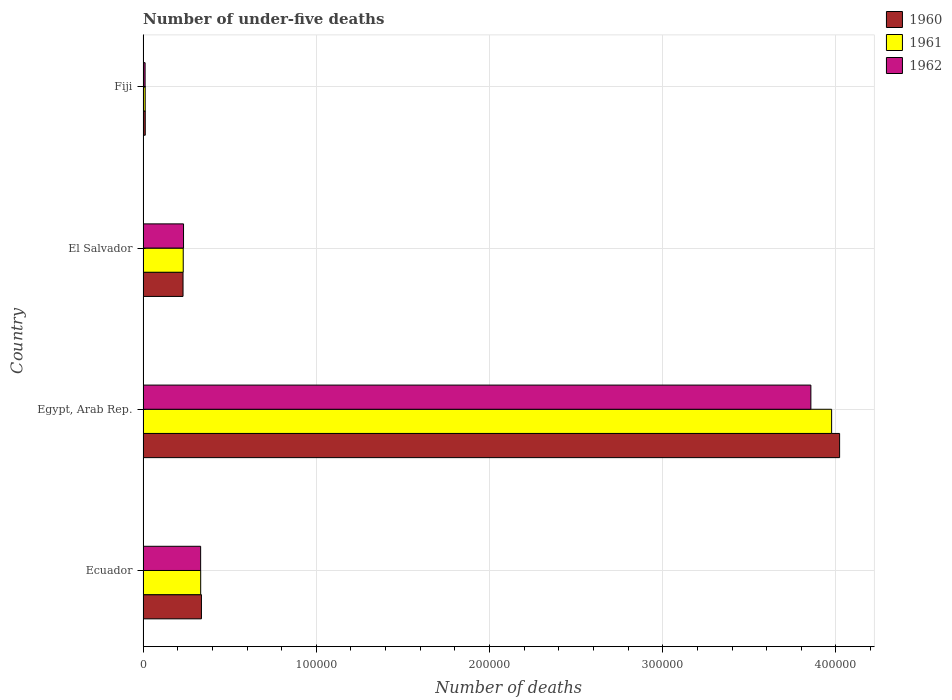Are the number of bars per tick equal to the number of legend labels?
Your response must be concise. Yes. Are the number of bars on each tick of the Y-axis equal?
Offer a very short reply. Yes. How many bars are there on the 4th tick from the top?
Offer a terse response. 3. What is the label of the 1st group of bars from the top?
Your answer should be very brief. Fiji. What is the number of under-five deaths in 1960 in Egypt, Arab Rep.?
Your response must be concise. 4.02e+05. Across all countries, what is the maximum number of under-five deaths in 1961?
Your response must be concise. 3.98e+05. Across all countries, what is the minimum number of under-five deaths in 1961?
Keep it short and to the point. 1222. In which country was the number of under-five deaths in 1962 maximum?
Offer a terse response. Egypt, Arab Rep. In which country was the number of under-five deaths in 1962 minimum?
Provide a short and direct response. Fiji. What is the total number of under-five deaths in 1961 in the graph?
Your answer should be very brief. 4.55e+05. What is the difference between the number of under-five deaths in 1960 in Egypt, Arab Rep. and that in El Salvador?
Give a very brief answer. 3.79e+05. What is the difference between the number of under-five deaths in 1962 in El Salvador and the number of under-five deaths in 1960 in Fiji?
Give a very brief answer. 2.21e+04. What is the average number of under-five deaths in 1961 per country?
Your response must be concise. 1.14e+05. In how many countries, is the number of under-five deaths in 1960 greater than 180000 ?
Ensure brevity in your answer.  1. What is the ratio of the number of under-five deaths in 1962 in El Salvador to that in Fiji?
Your answer should be compact. 19.87. Is the number of under-five deaths in 1960 in Egypt, Arab Rep. less than that in Fiji?
Give a very brief answer. No. What is the difference between the highest and the second highest number of under-five deaths in 1960?
Your response must be concise. 3.68e+05. What is the difference between the highest and the lowest number of under-five deaths in 1960?
Your response must be concise. 4.01e+05. Is the sum of the number of under-five deaths in 1961 in Egypt, Arab Rep. and Fiji greater than the maximum number of under-five deaths in 1960 across all countries?
Offer a very short reply. No. What does the 1st bar from the bottom in Egypt, Arab Rep. represents?
Your answer should be compact. 1960. Is it the case that in every country, the sum of the number of under-five deaths in 1962 and number of under-five deaths in 1961 is greater than the number of under-five deaths in 1960?
Your answer should be very brief. Yes. Does the graph contain any zero values?
Keep it short and to the point. No. Does the graph contain grids?
Your answer should be compact. Yes. How many legend labels are there?
Your answer should be compact. 3. What is the title of the graph?
Provide a succinct answer. Number of under-five deaths. Does "1964" appear as one of the legend labels in the graph?
Your answer should be very brief. No. What is the label or title of the X-axis?
Your answer should be compact. Number of deaths. What is the label or title of the Y-axis?
Ensure brevity in your answer.  Country. What is the Number of deaths of 1960 in Ecuador?
Make the answer very short. 3.37e+04. What is the Number of deaths of 1961 in Ecuador?
Ensure brevity in your answer.  3.33e+04. What is the Number of deaths of 1962 in Ecuador?
Your answer should be very brief. 3.32e+04. What is the Number of deaths in 1960 in Egypt, Arab Rep.?
Offer a very short reply. 4.02e+05. What is the Number of deaths of 1961 in Egypt, Arab Rep.?
Provide a succinct answer. 3.98e+05. What is the Number of deaths in 1962 in Egypt, Arab Rep.?
Offer a very short reply. 3.86e+05. What is the Number of deaths of 1960 in El Salvador?
Keep it short and to the point. 2.31e+04. What is the Number of deaths in 1961 in El Salvador?
Your answer should be compact. 2.32e+04. What is the Number of deaths in 1962 in El Salvador?
Your answer should be compact. 2.34e+04. What is the Number of deaths of 1960 in Fiji?
Offer a very short reply. 1263. What is the Number of deaths of 1961 in Fiji?
Your response must be concise. 1222. What is the Number of deaths in 1962 in Fiji?
Make the answer very short. 1176. Across all countries, what is the maximum Number of deaths of 1960?
Give a very brief answer. 4.02e+05. Across all countries, what is the maximum Number of deaths in 1961?
Offer a very short reply. 3.98e+05. Across all countries, what is the maximum Number of deaths of 1962?
Keep it short and to the point. 3.86e+05. Across all countries, what is the minimum Number of deaths of 1960?
Your answer should be compact. 1263. Across all countries, what is the minimum Number of deaths of 1961?
Give a very brief answer. 1222. Across all countries, what is the minimum Number of deaths in 1962?
Offer a terse response. 1176. What is the total Number of deaths in 1960 in the graph?
Keep it short and to the point. 4.60e+05. What is the total Number of deaths in 1961 in the graph?
Offer a very short reply. 4.55e+05. What is the total Number of deaths of 1962 in the graph?
Your answer should be very brief. 4.43e+05. What is the difference between the Number of deaths in 1960 in Ecuador and that in Egypt, Arab Rep.?
Your answer should be compact. -3.68e+05. What is the difference between the Number of deaths of 1961 in Ecuador and that in Egypt, Arab Rep.?
Provide a short and direct response. -3.64e+05. What is the difference between the Number of deaths in 1962 in Ecuador and that in Egypt, Arab Rep.?
Keep it short and to the point. -3.52e+05. What is the difference between the Number of deaths of 1960 in Ecuador and that in El Salvador?
Ensure brevity in your answer.  1.06e+04. What is the difference between the Number of deaths in 1961 in Ecuador and that in El Salvador?
Keep it short and to the point. 1.01e+04. What is the difference between the Number of deaths of 1962 in Ecuador and that in El Salvador?
Offer a terse response. 9875. What is the difference between the Number of deaths in 1960 in Ecuador and that in Fiji?
Provide a succinct answer. 3.24e+04. What is the difference between the Number of deaths in 1961 in Ecuador and that in Fiji?
Provide a succinct answer. 3.20e+04. What is the difference between the Number of deaths in 1962 in Ecuador and that in Fiji?
Keep it short and to the point. 3.21e+04. What is the difference between the Number of deaths in 1960 in Egypt, Arab Rep. and that in El Salvador?
Your answer should be compact. 3.79e+05. What is the difference between the Number of deaths of 1961 in Egypt, Arab Rep. and that in El Salvador?
Keep it short and to the point. 3.74e+05. What is the difference between the Number of deaths of 1962 in Egypt, Arab Rep. and that in El Salvador?
Ensure brevity in your answer.  3.62e+05. What is the difference between the Number of deaths of 1960 in Egypt, Arab Rep. and that in Fiji?
Offer a very short reply. 4.01e+05. What is the difference between the Number of deaths in 1961 in Egypt, Arab Rep. and that in Fiji?
Provide a short and direct response. 3.96e+05. What is the difference between the Number of deaths in 1962 in Egypt, Arab Rep. and that in Fiji?
Your response must be concise. 3.84e+05. What is the difference between the Number of deaths in 1960 in El Salvador and that in Fiji?
Keep it short and to the point. 2.18e+04. What is the difference between the Number of deaths in 1961 in El Salvador and that in Fiji?
Make the answer very short. 2.20e+04. What is the difference between the Number of deaths of 1962 in El Salvador and that in Fiji?
Make the answer very short. 2.22e+04. What is the difference between the Number of deaths in 1960 in Ecuador and the Number of deaths in 1961 in Egypt, Arab Rep.?
Offer a terse response. -3.64e+05. What is the difference between the Number of deaths in 1960 in Ecuador and the Number of deaths in 1962 in Egypt, Arab Rep.?
Provide a succinct answer. -3.52e+05. What is the difference between the Number of deaths in 1961 in Ecuador and the Number of deaths in 1962 in Egypt, Arab Rep.?
Keep it short and to the point. -3.52e+05. What is the difference between the Number of deaths of 1960 in Ecuador and the Number of deaths of 1961 in El Salvador?
Your response must be concise. 1.05e+04. What is the difference between the Number of deaths in 1960 in Ecuador and the Number of deaths in 1962 in El Salvador?
Your response must be concise. 1.03e+04. What is the difference between the Number of deaths of 1961 in Ecuador and the Number of deaths of 1962 in El Salvador?
Provide a short and direct response. 9900. What is the difference between the Number of deaths of 1960 in Ecuador and the Number of deaths of 1961 in Fiji?
Keep it short and to the point. 3.25e+04. What is the difference between the Number of deaths of 1960 in Ecuador and the Number of deaths of 1962 in Fiji?
Your response must be concise. 3.25e+04. What is the difference between the Number of deaths in 1961 in Ecuador and the Number of deaths in 1962 in Fiji?
Keep it short and to the point. 3.21e+04. What is the difference between the Number of deaths in 1960 in Egypt, Arab Rep. and the Number of deaths in 1961 in El Salvador?
Your answer should be compact. 3.79e+05. What is the difference between the Number of deaths in 1960 in Egypt, Arab Rep. and the Number of deaths in 1962 in El Salvador?
Your answer should be compact. 3.79e+05. What is the difference between the Number of deaths of 1961 in Egypt, Arab Rep. and the Number of deaths of 1962 in El Salvador?
Keep it short and to the point. 3.74e+05. What is the difference between the Number of deaths in 1960 in Egypt, Arab Rep. and the Number of deaths in 1961 in Fiji?
Provide a succinct answer. 4.01e+05. What is the difference between the Number of deaths of 1960 in Egypt, Arab Rep. and the Number of deaths of 1962 in Fiji?
Your response must be concise. 4.01e+05. What is the difference between the Number of deaths in 1961 in Egypt, Arab Rep. and the Number of deaths in 1962 in Fiji?
Provide a succinct answer. 3.96e+05. What is the difference between the Number of deaths in 1960 in El Salvador and the Number of deaths in 1961 in Fiji?
Keep it short and to the point. 2.19e+04. What is the difference between the Number of deaths of 1960 in El Salvador and the Number of deaths of 1962 in Fiji?
Offer a terse response. 2.19e+04. What is the difference between the Number of deaths of 1961 in El Salvador and the Number of deaths of 1962 in Fiji?
Your answer should be very brief. 2.20e+04. What is the average Number of deaths of 1960 per country?
Offer a very short reply. 1.15e+05. What is the average Number of deaths of 1961 per country?
Offer a very short reply. 1.14e+05. What is the average Number of deaths of 1962 per country?
Ensure brevity in your answer.  1.11e+05. What is the difference between the Number of deaths of 1960 and Number of deaths of 1961 in Ecuador?
Offer a terse response. 433. What is the difference between the Number of deaths in 1960 and Number of deaths in 1962 in Ecuador?
Your answer should be very brief. 458. What is the difference between the Number of deaths in 1960 and Number of deaths in 1961 in Egypt, Arab Rep.?
Provide a succinct answer. 4607. What is the difference between the Number of deaths of 1960 and Number of deaths of 1962 in Egypt, Arab Rep.?
Keep it short and to the point. 1.66e+04. What is the difference between the Number of deaths in 1961 and Number of deaths in 1962 in Egypt, Arab Rep.?
Your response must be concise. 1.20e+04. What is the difference between the Number of deaths in 1960 and Number of deaths in 1961 in El Salvador?
Offer a terse response. -118. What is the difference between the Number of deaths in 1960 and Number of deaths in 1962 in El Salvador?
Your answer should be very brief. -293. What is the difference between the Number of deaths in 1961 and Number of deaths in 1962 in El Salvador?
Offer a terse response. -175. What is the difference between the Number of deaths of 1960 and Number of deaths of 1961 in Fiji?
Keep it short and to the point. 41. What is the difference between the Number of deaths of 1960 and Number of deaths of 1962 in Fiji?
Your answer should be compact. 87. What is the ratio of the Number of deaths in 1960 in Ecuador to that in Egypt, Arab Rep.?
Your answer should be very brief. 0.08. What is the ratio of the Number of deaths in 1961 in Ecuador to that in Egypt, Arab Rep.?
Offer a very short reply. 0.08. What is the ratio of the Number of deaths of 1962 in Ecuador to that in Egypt, Arab Rep.?
Make the answer very short. 0.09. What is the ratio of the Number of deaths of 1960 in Ecuador to that in El Salvador?
Your response must be concise. 1.46. What is the ratio of the Number of deaths in 1961 in Ecuador to that in El Salvador?
Offer a very short reply. 1.43. What is the ratio of the Number of deaths in 1962 in Ecuador to that in El Salvador?
Provide a succinct answer. 1.42. What is the ratio of the Number of deaths in 1960 in Ecuador to that in Fiji?
Offer a very short reply. 26.68. What is the ratio of the Number of deaths in 1961 in Ecuador to that in Fiji?
Give a very brief answer. 27.22. What is the ratio of the Number of deaths of 1962 in Ecuador to that in Fiji?
Your response must be concise. 28.27. What is the ratio of the Number of deaths of 1960 in Egypt, Arab Rep. to that in El Salvador?
Provide a succinct answer. 17.43. What is the ratio of the Number of deaths in 1961 in Egypt, Arab Rep. to that in El Salvador?
Provide a short and direct response. 17.14. What is the ratio of the Number of deaths in 1962 in Egypt, Arab Rep. to that in El Salvador?
Ensure brevity in your answer.  16.5. What is the ratio of the Number of deaths of 1960 in Egypt, Arab Rep. to that in Fiji?
Your answer should be very brief. 318.38. What is the ratio of the Number of deaths of 1961 in Egypt, Arab Rep. to that in Fiji?
Offer a terse response. 325.29. What is the ratio of the Number of deaths of 1962 in Egypt, Arab Rep. to that in Fiji?
Your answer should be very brief. 327.83. What is the ratio of the Number of deaths in 1960 in El Salvador to that in Fiji?
Offer a terse response. 18.27. What is the ratio of the Number of deaths in 1961 in El Salvador to that in Fiji?
Offer a very short reply. 18.98. What is the ratio of the Number of deaths in 1962 in El Salvador to that in Fiji?
Provide a short and direct response. 19.87. What is the difference between the highest and the second highest Number of deaths of 1960?
Offer a terse response. 3.68e+05. What is the difference between the highest and the second highest Number of deaths in 1961?
Make the answer very short. 3.64e+05. What is the difference between the highest and the second highest Number of deaths in 1962?
Keep it short and to the point. 3.52e+05. What is the difference between the highest and the lowest Number of deaths in 1960?
Your answer should be very brief. 4.01e+05. What is the difference between the highest and the lowest Number of deaths of 1961?
Provide a succinct answer. 3.96e+05. What is the difference between the highest and the lowest Number of deaths of 1962?
Provide a succinct answer. 3.84e+05. 